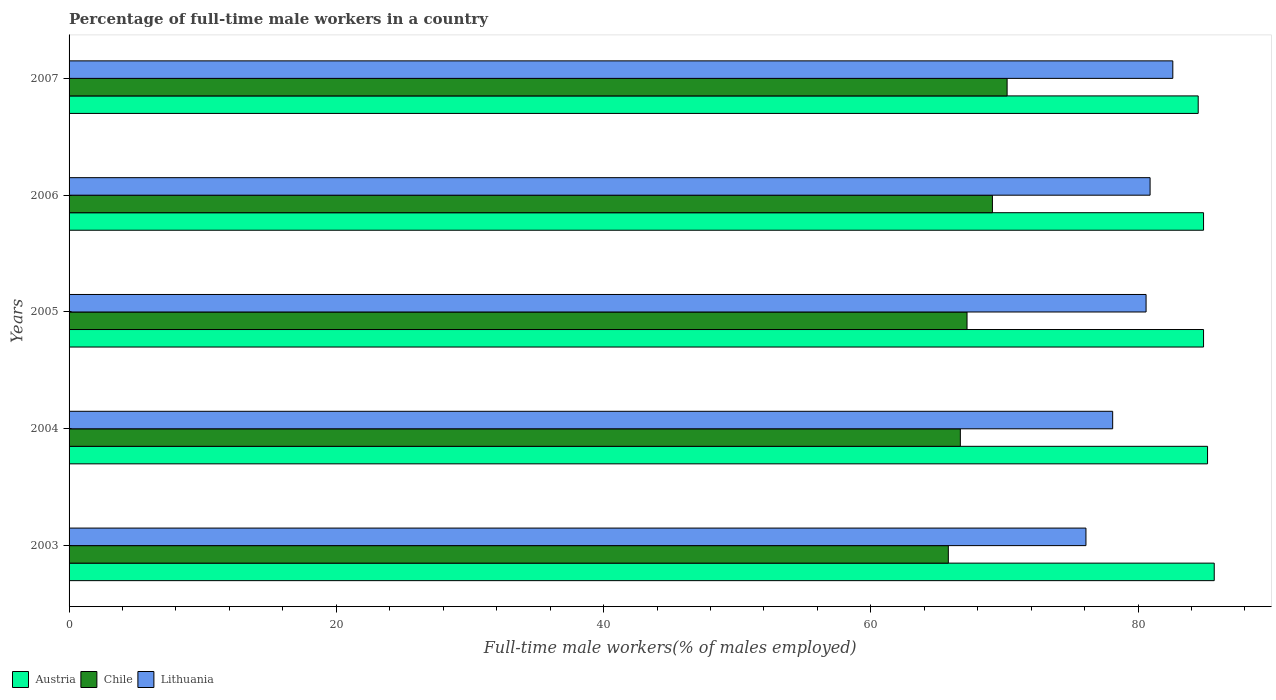How many different coloured bars are there?
Your answer should be compact. 3. How many groups of bars are there?
Your response must be concise. 5. Are the number of bars on each tick of the Y-axis equal?
Give a very brief answer. Yes. How many bars are there on the 5th tick from the bottom?
Your answer should be very brief. 3. What is the label of the 2nd group of bars from the top?
Provide a succinct answer. 2006. What is the percentage of full-time male workers in Austria in 2003?
Your answer should be very brief. 85.7. Across all years, what is the maximum percentage of full-time male workers in Chile?
Your answer should be very brief. 70.2. Across all years, what is the minimum percentage of full-time male workers in Lithuania?
Offer a terse response. 76.1. In which year was the percentage of full-time male workers in Lithuania maximum?
Your answer should be very brief. 2007. What is the total percentage of full-time male workers in Lithuania in the graph?
Offer a very short reply. 398.3. What is the difference between the percentage of full-time male workers in Austria in 2006 and that in 2007?
Your answer should be compact. 0.4. What is the difference between the percentage of full-time male workers in Lithuania in 2005 and the percentage of full-time male workers in Austria in 2007?
Your answer should be compact. -3.9. What is the average percentage of full-time male workers in Chile per year?
Keep it short and to the point. 67.8. In the year 2006, what is the difference between the percentage of full-time male workers in Lithuania and percentage of full-time male workers in Austria?
Your answer should be compact. -4. In how many years, is the percentage of full-time male workers in Chile greater than 72 %?
Offer a very short reply. 0. What is the ratio of the percentage of full-time male workers in Austria in 2004 to that in 2007?
Offer a terse response. 1.01. Is the percentage of full-time male workers in Austria in 2003 less than that in 2006?
Provide a short and direct response. No. What is the difference between the highest and the second highest percentage of full-time male workers in Chile?
Your answer should be very brief. 1.1. Is the sum of the percentage of full-time male workers in Austria in 2003 and 2005 greater than the maximum percentage of full-time male workers in Lithuania across all years?
Make the answer very short. Yes. What does the 3rd bar from the bottom in 2005 represents?
Your answer should be compact. Lithuania. Is it the case that in every year, the sum of the percentage of full-time male workers in Lithuania and percentage of full-time male workers in Chile is greater than the percentage of full-time male workers in Austria?
Offer a very short reply. Yes. Does the graph contain grids?
Provide a short and direct response. No. Where does the legend appear in the graph?
Your answer should be very brief. Bottom left. How are the legend labels stacked?
Ensure brevity in your answer.  Horizontal. What is the title of the graph?
Give a very brief answer. Percentage of full-time male workers in a country. Does "Burundi" appear as one of the legend labels in the graph?
Provide a short and direct response. No. What is the label or title of the X-axis?
Your answer should be compact. Full-time male workers(% of males employed). What is the Full-time male workers(% of males employed) of Austria in 2003?
Your answer should be compact. 85.7. What is the Full-time male workers(% of males employed) in Chile in 2003?
Keep it short and to the point. 65.8. What is the Full-time male workers(% of males employed) in Lithuania in 2003?
Give a very brief answer. 76.1. What is the Full-time male workers(% of males employed) of Austria in 2004?
Ensure brevity in your answer.  85.2. What is the Full-time male workers(% of males employed) in Chile in 2004?
Your response must be concise. 66.7. What is the Full-time male workers(% of males employed) in Lithuania in 2004?
Your response must be concise. 78.1. What is the Full-time male workers(% of males employed) in Austria in 2005?
Your response must be concise. 84.9. What is the Full-time male workers(% of males employed) in Chile in 2005?
Make the answer very short. 67.2. What is the Full-time male workers(% of males employed) in Lithuania in 2005?
Ensure brevity in your answer.  80.6. What is the Full-time male workers(% of males employed) in Austria in 2006?
Provide a succinct answer. 84.9. What is the Full-time male workers(% of males employed) of Chile in 2006?
Give a very brief answer. 69.1. What is the Full-time male workers(% of males employed) of Lithuania in 2006?
Provide a succinct answer. 80.9. What is the Full-time male workers(% of males employed) in Austria in 2007?
Your response must be concise. 84.5. What is the Full-time male workers(% of males employed) in Chile in 2007?
Your answer should be compact. 70.2. What is the Full-time male workers(% of males employed) of Lithuania in 2007?
Offer a very short reply. 82.6. Across all years, what is the maximum Full-time male workers(% of males employed) in Austria?
Your answer should be very brief. 85.7. Across all years, what is the maximum Full-time male workers(% of males employed) in Chile?
Ensure brevity in your answer.  70.2. Across all years, what is the maximum Full-time male workers(% of males employed) in Lithuania?
Provide a succinct answer. 82.6. Across all years, what is the minimum Full-time male workers(% of males employed) in Austria?
Ensure brevity in your answer.  84.5. Across all years, what is the minimum Full-time male workers(% of males employed) in Chile?
Provide a succinct answer. 65.8. Across all years, what is the minimum Full-time male workers(% of males employed) of Lithuania?
Offer a very short reply. 76.1. What is the total Full-time male workers(% of males employed) in Austria in the graph?
Keep it short and to the point. 425.2. What is the total Full-time male workers(% of males employed) in Chile in the graph?
Ensure brevity in your answer.  339. What is the total Full-time male workers(% of males employed) in Lithuania in the graph?
Make the answer very short. 398.3. What is the difference between the Full-time male workers(% of males employed) in Austria in 2003 and that in 2005?
Provide a short and direct response. 0.8. What is the difference between the Full-time male workers(% of males employed) in Lithuania in 2003 and that in 2005?
Your answer should be very brief. -4.5. What is the difference between the Full-time male workers(% of males employed) of Lithuania in 2003 and that in 2006?
Make the answer very short. -4.8. What is the difference between the Full-time male workers(% of males employed) of Austria in 2004 and that in 2005?
Give a very brief answer. 0.3. What is the difference between the Full-time male workers(% of males employed) of Austria in 2004 and that in 2007?
Offer a terse response. 0.7. What is the difference between the Full-time male workers(% of males employed) of Chile in 2004 and that in 2007?
Your answer should be compact. -3.5. What is the difference between the Full-time male workers(% of males employed) of Lithuania in 2004 and that in 2007?
Provide a short and direct response. -4.5. What is the difference between the Full-time male workers(% of males employed) of Chile in 2005 and that in 2006?
Your answer should be compact. -1.9. What is the difference between the Full-time male workers(% of males employed) of Lithuania in 2005 and that in 2006?
Keep it short and to the point. -0.3. What is the difference between the Full-time male workers(% of males employed) in Austria in 2005 and that in 2007?
Give a very brief answer. 0.4. What is the difference between the Full-time male workers(% of males employed) in Chile in 2005 and that in 2007?
Provide a short and direct response. -3. What is the difference between the Full-time male workers(% of males employed) of Chile in 2006 and that in 2007?
Make the answer very short. -1.1. What is the difference between the Full-time male workers(% of males employed) of Lithuania in 2006 and that in 2007?
Offer a terse response. -1.7. What is the difference between the Full-time male workers(% of males employed) in Austria in 2003 and the Full-time male workers(% of males employed) in Chile in 2004?
Your answer should be very brief. 19. What is the difference between the Full-time male workers(% of males employed) in Austria in 2003 and the Full-time male workers(% of males employed) in Lithuania in 2004?
Keep it short and to the point. 7.6. What is the difference between the Full-time male workers(% of males employed) of Chile in 2003 and the Full-time male workers(% of males employed) of Lithuania in 2004?
Make the answer very short. -12.3. What is the difference between the Full-time male workers(% of males employed) of Austria in 2003 and the Full-time male workers(% of males employed) of Lithuania in 2005?
Make the answer very short. 5.1. What is the difference between the Full-time male workers(% of males employed) in Chile in 2003 and the Full-time male workers(% of males employed) in Lithuania in 2005?
Keep it short and to the point. -14.8. What is the difference between the Full-time male workers(% of males employed) in Austria in 2003 and the Full-time male workers(% of males employed) in Chile in 2006?
Offer a terse response. 16.6. What is the difference between the Full-time male workers(% of males employed) of Chile in 2003 and the Full-time male workers(% of males employed) of Lithuania in 2006?
Keep it short and to the point. -15.1. What is the difference between the Full-time male workers(% of males employed) in Chile in 2003 and the Full-time male workers(% of males employed) in Lithuania in 2007?
Make the answer very short. -16.8. What is the difference between the Full-time male workers(% of males employed) in Austria in 2004 and the Full-time male workers(% of males employed) in Chile in 2005?
Keep it short and to the point. 18. What is the difference between the Full-time male workers(% of males employed) of Austria in 2004 and the Full-time male workers(% of males employed) of Lithuania in 2005?
Keep it short and to the point. 4.6. What is the difference between the Full-time male workers(% of males employed) of Austria in 2004 and the Full-time male workers(% of males employed) of Chile in 2007?
Offer a terse response. 15. What is the difference between the Full-time male workers(% of males employed) of Chile in 2004 and the Full-time male workers(% of males employed) of Lithuania in 2007?
Ensure brevity in your answer.  -15.9. What is the difference between the Full-time male workers(% of males employed) in Austria in 2005 and the Full-time male workers(% of males employed) in Chile in 2006?
Your answer should be very brief. 15.8. What is the difference between the Full-time male workers(% of males employed) of Chile in 2005 and the Full-time male workers(% of males employed) of Lithuania in 2006?
Offer a very short reply. -13.7. What is the difference between the Full-time male workers(% of males employed) of Chile in 2005 and the Full-time male workers(% of males employed) of Lithuania in 2007?
Offer a terse response. -15.4. What is the difference between the Full-time male workers(% of males employed) in Chile in 2006 and the Full-time male workers(% of males employed) in Lithuania in 2007?
Ensure brevity in your answer.  -13.5. What is the average Full-time male workers(% of males employed) of Austria per year?
Keep it short and to the point. 85.04. What is the average Full-time male workers(% of males employed) in Chile per year?
Your answer should be compact. 67.8. What is the average Full-time male workers(% of males employed) in Lithuania per year?
Keep it short and to the point. 79.66. In the year 2004, what is the difference between the Full-time male workers(% of males employed) in Austria and Full-time male workers(% of males employed) in Lithuania?
Make the answer very short. 7.1. In the year 2005, what is the difference between the Full-time male workers(% of males employed) in Austria and Full-time male workers(% of males employed) in Chile?
Give a very brief answer. 17.7. In the year 2006, what is the difference between the Full-time male workers(% of males employed) in Austria and Full-time male workers(% of males employed) in Lithuania?
Provide a short and direct response. 4. In the year 2006, what is the difference between the Full-time male workers(% of males employed) in Chile and Full-time male workers(% of males employed) in Lithuania?
Give a very brief answer. -11.8. In the year 2007, what is the difference between the Full-time male workers(% of males employed) of Austria and Full-time male workers(% of males employed) of Chile?
Offer a very short reply. 14.3. What is the ratio of the Full-time male workers(% of males employed) of Austria in 2003 to that in 2004?
Your answer should be very brief. 1.01. What is the ratio of the Full-time male workers(% of males employed) of Chile in 2003 to that in 2004?
Ensure brevity in your answer.  0.99. What is the ratio of the Full-time male workers(% of males employed) in Lithuania in 2003 to that in 2004?
Your answer should be compact. 0.97. What is the ratio of the Full-time male workers(% of males employed) in Austria in 2003 to that in 2005?
Provide a short and direct response. 1.01. What is the ratio of the Full-time male workers(% of males employed) of Chile in 2003 to that in 2005?
Offer a terse response. 0.98. What is the ratio of the Full-time male workers(% of males employed) of Lithuania in 2003 to that in 2005?
Your response must be concise. 0.94. What is the ratio of the Full-time male workers(% of males employed) in Austria in 2003 to that in 2006?
Make the answer very short. 1.01. What is the ratio of the Full-time male workers(% of males employed) of Chile in 2003 to that in 2006?
Offer a very short reply. 0.95. What is the ratio of the Full-time male workers(% of males employed) of Lithuania in 2003 to that in 2006?
Your answer should be very brief. 0.94. What is the ratio of the Full-time male workers(% of males employed) of Austria in 2003 to that in 2007?
Keep it short and to the point. 1.01. What is the ratio of the Full-time male workers(% of males employed) in Chile in 2003 to that in 2007?
Make the answer very short. 0.94. What is the ratio of the Full-time male workers(% of males employed) in Lithuania in 2003 to that in 2007?
Keep it short and to the point. 0.92. What is the ratio of the Full-time male workers(% of males employed) of Austria in 2004 to that in 2005?
Provide a succinct answer. 1. What is the ratio of the Full-time male workers(% of males employed) in Lithuania in 2004 to that in 2005?
Offer a terse response. 0.97. What is the ratio of the Full-time male workers(% of males employed) of Chile in 2004 to that in 2006?
Ensure brevity in your answer.  0.97. What is the ratio of the Full-time male workers(% of males employed) in Lithuania in 2004 to that in 2006?
Your answer should be very brief. 0.97. What is the ratio of the Full-time male workers(% of males employed) of Austria in 2004 to that in 2007?
Keep it short and to the point. 1.01. What is the ratio of the Full-time male workers(% of males employed) of Chile in 2004 to that in 2007?
Your response must be concise. 0.95. What is the ratio of the Full-time male workers(% of males employed) of Lithuania in 2004 to that in 2007?
Provide a short and direct response. 0.95. What is the ratio of the Full-time male workers(% of males employed) in Austria in 2005 to that in 2006?
Your response must be concise. 1. What is the ratio of the Full-time male workers(% of males employed) in Chile in 2005 to that in 2006?
Give a very brief answer. 0.97. What is the ratio of the Full-time male workers(% of males employed) in Lithuania in 2005 to that in 2006?
Provide a succinct answer. 1. What is the ratio of the Full-time male workers(% of males employed) of Austria in 2005 to that in 2007?
Your response must be concise. 1. What is the ratio of the Full-time male workers(% of males employed) of Chile in 2005 to that in 2007?
Your response must be concise. 0.96. What is the ratio of the Full-time male workers(% of males employed) in Lithuania in 2005 to that in 2007?
Provide a succinct answer. 0.98. What is the ratio of the Full-time male workers(% of males employed) of Chile in 2006 to that in 2007?
Keep it short and to the point. 0.98. What is the ratio of the Full-time male workers(% of males employed) of Lithuania in 2006 to that in 2007?
Your answer should be very brief. 0.98. What is the difference between the highest and the second highest Full-time male workers(% of males employed) in Chile?
Give a very brief answer. 1.1. What is the difference between the highest and the second highest Full-time male workers(% of males employed) in Lithuania?
Ensure brevity in your answer.  1.7. What is the difference between the highest and the lowest Full-time male workers(% of males employed) in Chile?
Provide a short and direct response. 4.4. 